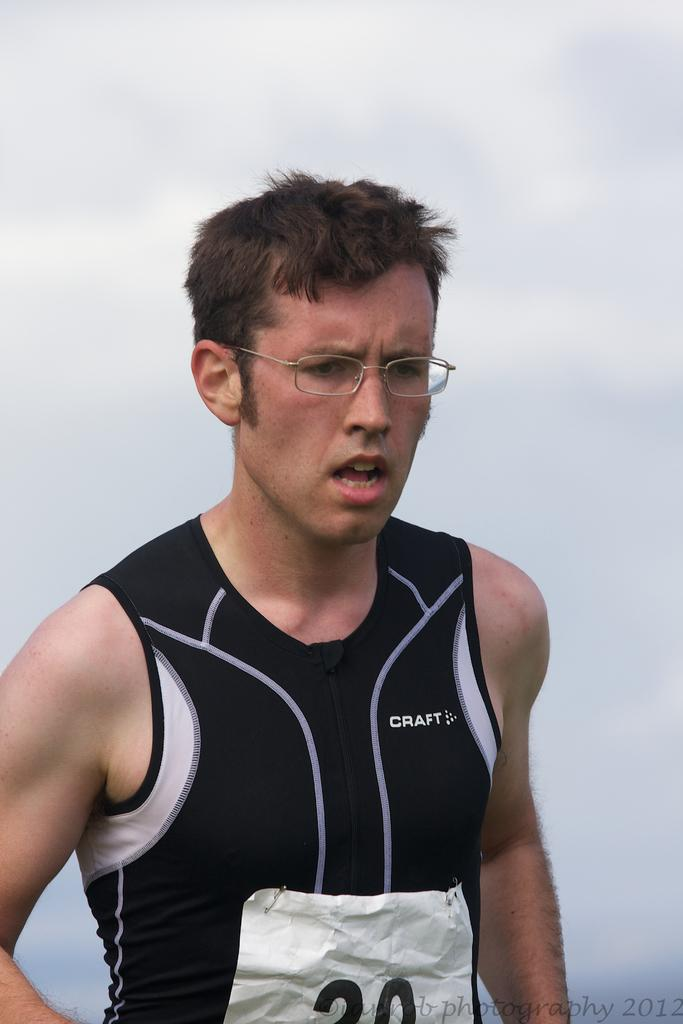<image>
Render a clear and concise summary of the photo. The male athlete shown is wearing clothing made by the company Craft. 